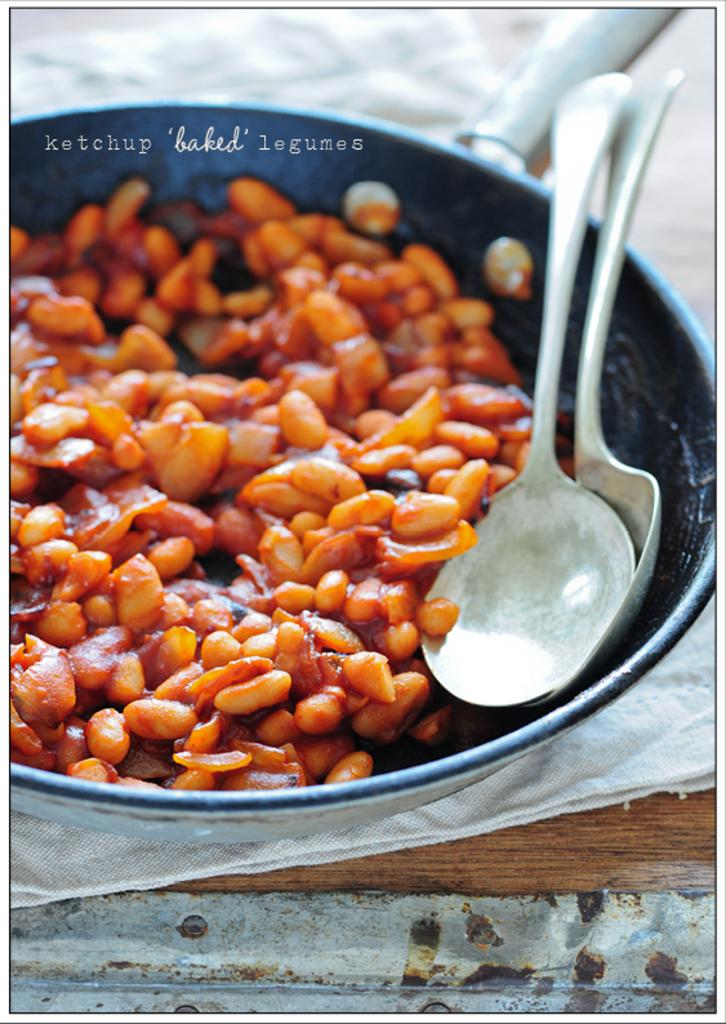What type of food can be seen in the image? There are peanuts in the image. What is the peanuts contained in? The peanuts are in a bowl. What utensils are associated with the bowl? Spoons are kept on the bowl. Where is the bowl placed? The bowl is placed on a table. How many apples are hanging from the bulb in the image? There are no apples or bulbs present in the image. What type of farmer is shown in the image? There is no farmer present in the image. 